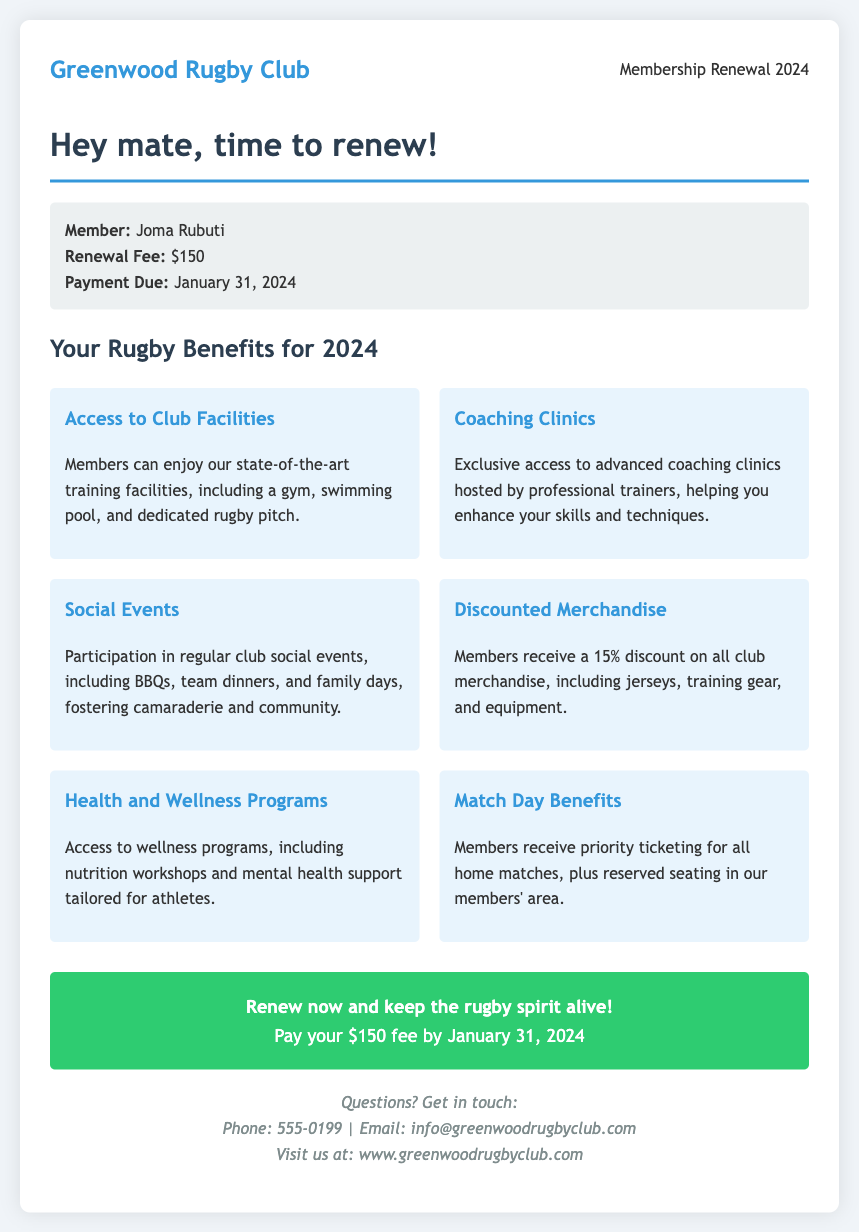What is the renewal fee for 2024? The renewal fee for 2024 is explicitly stated in the document as $150.
Answer: $150 What is the payment due date? The document specifies that the payment is due on January 31, 2024.
Answer: January 31, 2024 What facilities can members access? The document mentions state-of-the-art training facilities, which include a gym, swimming pool, and rugby pitch.
Answer: Gym, swimming pool, rugby pitch What discount do members receive on merchandise? The document indicates that members receive a 15% discount on all club merchandise.
Answer: 15% What type of events can members participate in? The document lists regular club social events, such as BBQs, team dinners, and family days, as activities for members.
Answer: Social events What benefits do members receive on match days? Members receive priority ticketing for home matches and reserved seating in the members' area, according to the document.
Answer: Priority ticketing, reserved seating What wellness programs are available to members? The document mentions access to wellness programs, including nutrition workshops and mental health support.
Answer: Wellness programs What is the main message encouraging renewal? The document emphasizes the importance of renewing membership to keep the rugby spirit alive.
Answer: Keep the rugby spirit alive 